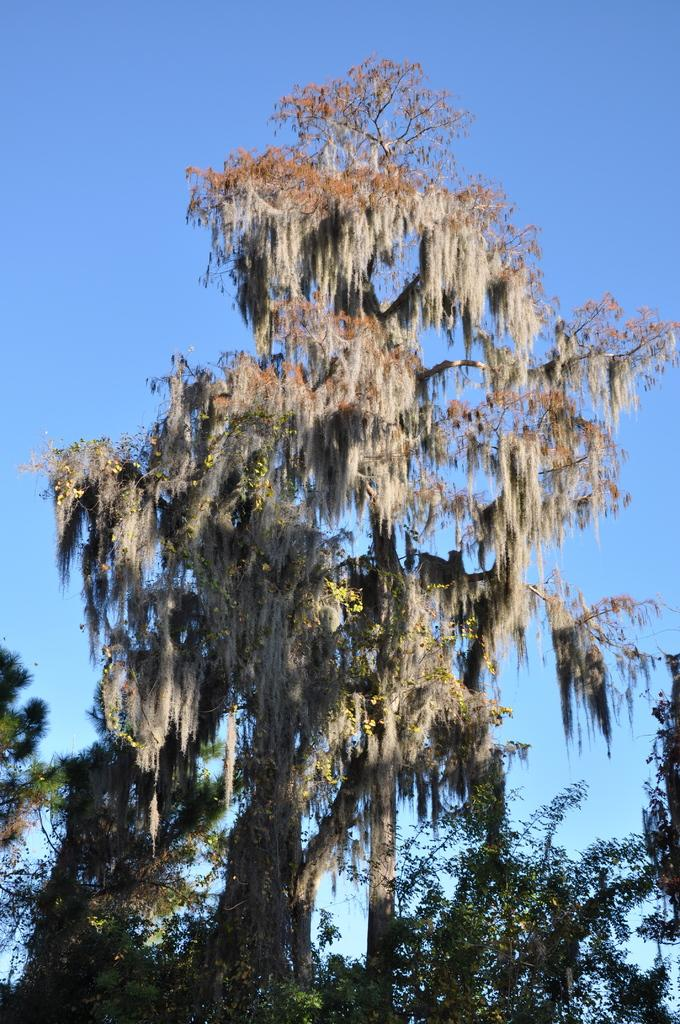Where was the image taken? The image was taken outdoors. What can be seen at the top of the image? The sky is visible at the top of the image. What type of vegetation is present in the image? There are trees with green leaves, stems, and branches in the middle of the image. What book is the person reading while jumping in the image? There is no person reading a book or jumping in the image; it features trees with green leaves, stems, and branches. 